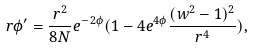<formula> <loc_0><loc_0><loc_500><loc_500>r \phi ^ { \prime } = \frac { r ^ { 2 } } { 8 N } e ^ { - 2 \phi } ( 1 - 4 e ^ { 4 \phi } \frac { ( w ^ { 2 } - 1 ) ^ { 2 } } { r ^ { 4 } } ) ,</formula> 